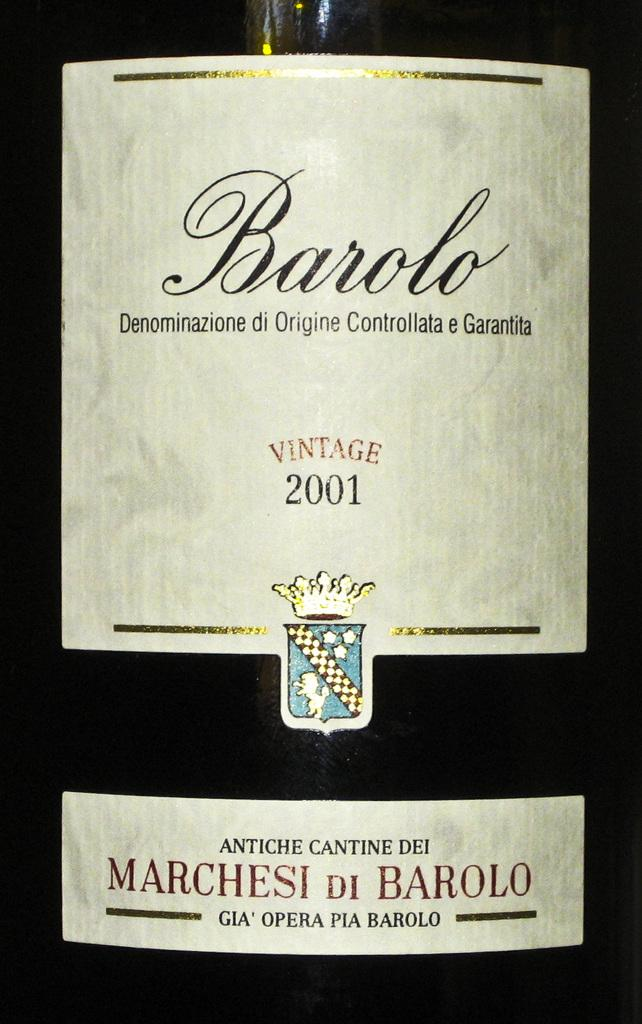<image>
Offer a succinct explanation of the picture presented. bottle of 2001 barolo denominazione di origine controllata e garantita 